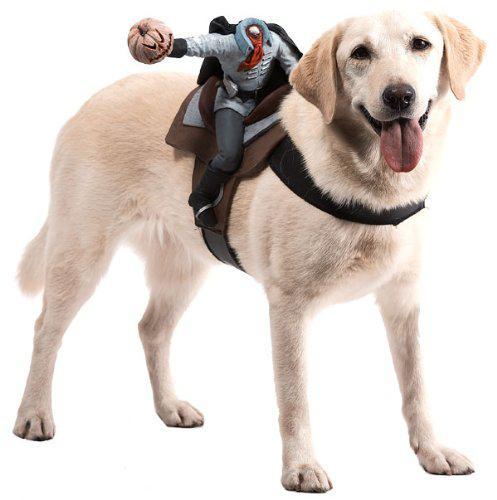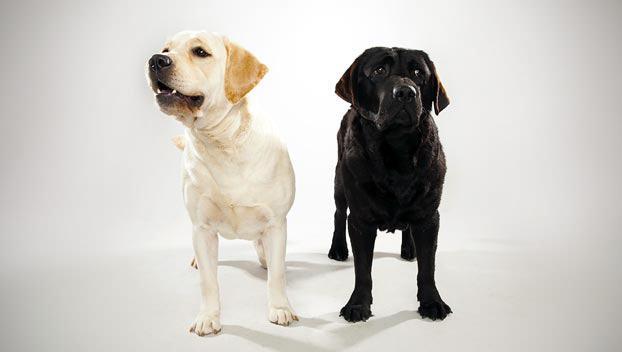The first image is the image on the left, the second image is the image on the right. For the images shown, is this caption "There are two dogs in the image on the right." true? Answer yes or no. Yes. 